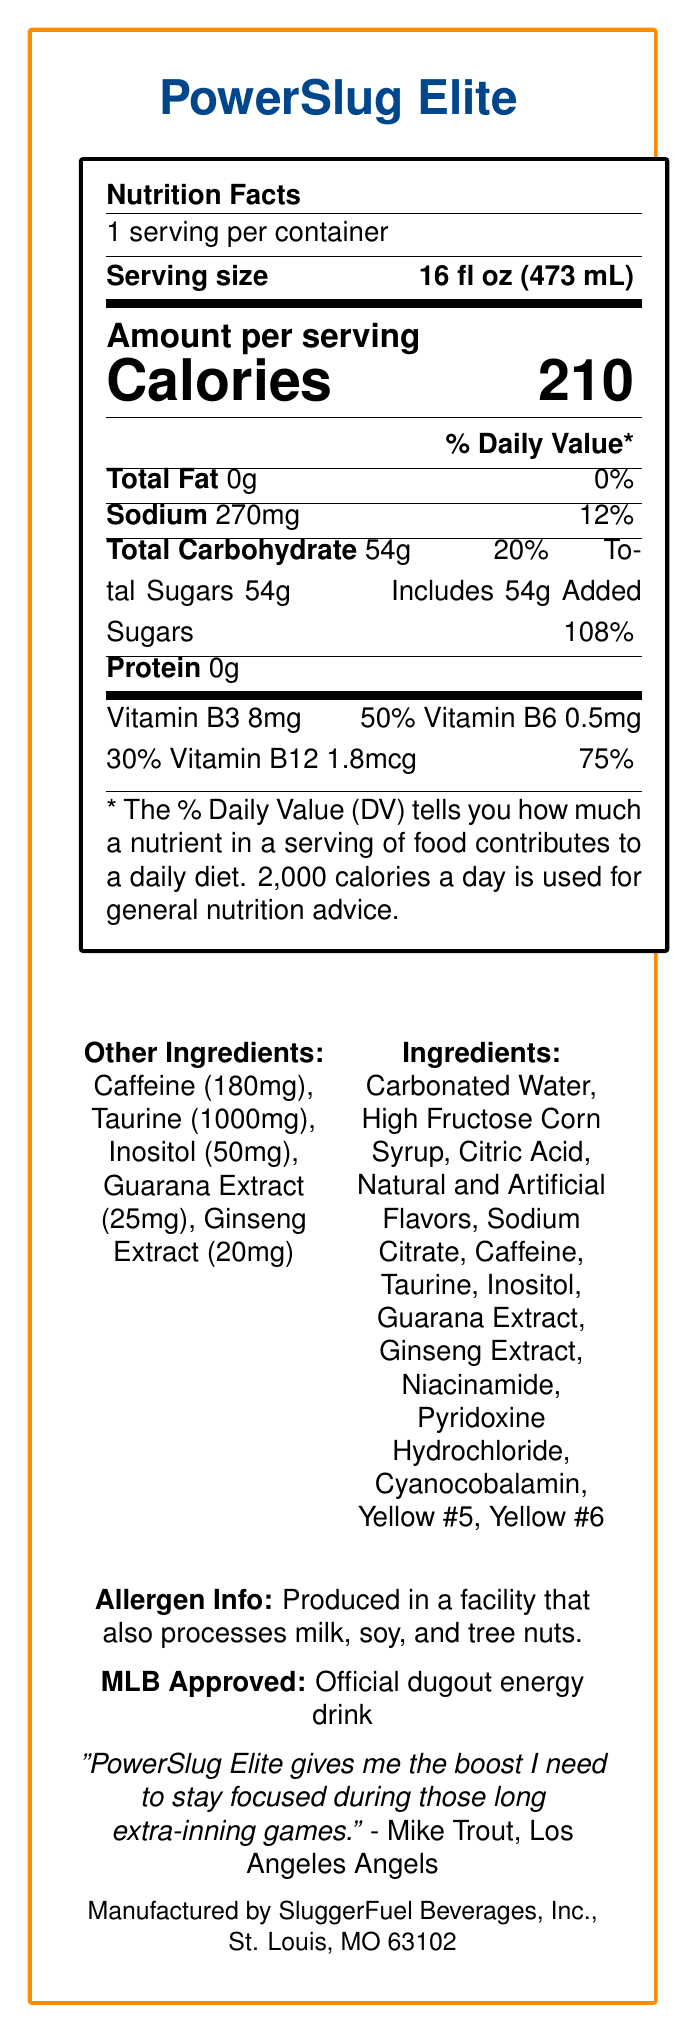What is the serving size of PowerSlug Elite? The document states that the serving size is 16 fl oz (473 mL).
Answer: 16 fl oz (473 mL) How many calories are there per serving of PowerSlug Elite? The document specifies that there are 210 calories per serving.
Answer: 210 calories What percentage of the daily value does the sodium content represent? The document indicates that the sodium content is 270mg, representing 12% of the daily value.
Answer: 12% How much protein is in a serving of PowerSlug Elite? The document lists the protein content as 0g.
Answer: 0g What amount of Vitamin B12 is present in each serving? The document mentions that each serving contains 1.8mcg of Vitamin B12.
Answer: 1.8mcg Which MLB team is PowerSlug Elite the official energy drink for? The document notes that PowerSlug Elite is the official energy drink of the New York Yankees.
Answer: New York Yankees What is the total carbohydrate content per serving? The document specifies that the total carbohydrate content per serving is 54g.
Answer: 54g Which famous baseball player endorses PowerSlug Elite? A. Mike Trout B. Aaron Judge C. Mookie Betts D. Bryce Harper The document contains a testimonial from Mike Trout endorsing PowerSlug Elite.
Answer: A How much caffeine is in each serving? The document states that there is 180mg of caffeine per serving.
Answer: 180mg Which ingredient is present in the highest quantity in PowerSlug Elite? A. Taurlne B. Inositol C. Guarana Extract D. Ginseng Extract The document specifies that the amount of taurine is 1000mg, which is the highest among the listed ingredients.
Answer: A Is PowerSlug Elite produced in a facility that processes tree nuts? (Yes/No) The document states that it is produced in a facility that also processes milk, soy, and tree nuts.
Answer: Yes Describe the main nutritional content and additional information provided for PowerSlug Elite. The document outlines the nutritional facts of PowerSlug Elite, details about caffeine and other key ingredients, manufacturing and approval information, and endorsements by MLB and prominent players.
Answer: PowerSlug Elite has a serving size of 16 fl oz, contains 210 calories per serving, and includes nutrients such as 270mg of sodium (12% DV), 54g of total carbohydrates (20% DV) including 54g of added sugars (108% DV), and no protein. Key vitamins include B3, B6, and B12. It contains caffeine, taurine, inositol, guarana extract, and ginseng extract. It's manufactured by SluggerFuel Beverages, endorsed by MLB, and favored by several categories of players. What are the natural and artificial colorings used in PowerSlug Elite? The document lists Yellow #5 and Yellow #6 as ingredients.
Answer: Yellow #5, Yellow #6 How many servings are there in one container of PowerSlug Elite? The document specifies that there is 1 serving per container.
Answer: 1 Which vitamins are included in PowerSlug Elite and what are their respective amounts? The document provides these amounts for each of the vitamins included in PowerSlug Elite.
Answer: Vitamin B3: 8mg, Vitamin B6: 0.5mg, Vitamin B12: 1.8mcg How much taurine is in a serving? The document lists the taurine content as 1000mg per serving.
Answer: 1000mg Why is PowerSlug Elite favored among relief pitchers and outfielders during doubleheaders? The document mentions that PowerSlug Elite is popular among those player categories but does not specify why.
Answer: Not enough information 